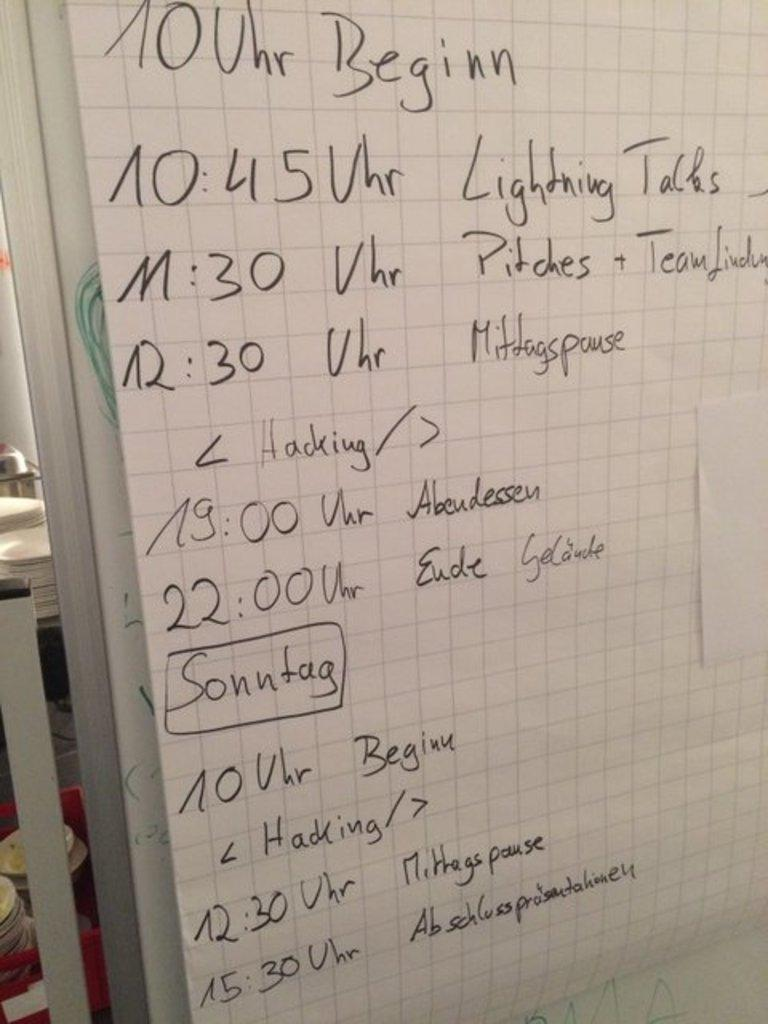Provide a one-sentence caption for the provided image. On a large sheet of graph paper, draped over a dry erase board is an event schedule that goes from 10:00 to 15:30. 